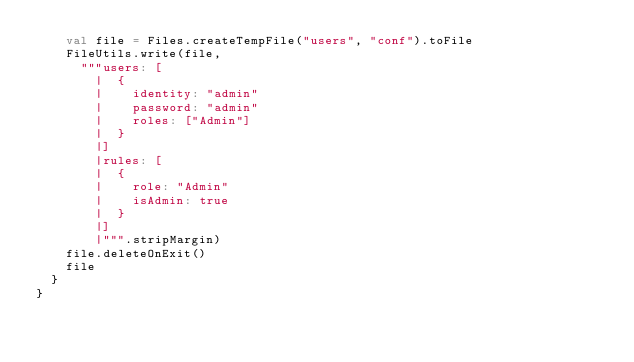<code> <loc_0><loc_0><loc_500><loc_500><_Scala_>    val file = Files.createTempFile("users", "conf").toFile
    FileUtils.write(file,
      """users: [
        |  {
        |    identity: "admin"
        |    password: "admin"
        |    roles: ["Admin"]
        |  }
        |]
        |rules: [
        |  {
        |    role: "Admin"
        |    isAdmin: true
        |  }
        |]
        |""".stripMargin)
    file.deleteOnExit()
    file
  }
}
</code> 